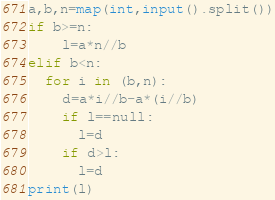<code> <loc_0><loc_0><loc_500><loc_500><_Python_>a,b,n=map(int,input().split())
if b>=n:
	l=a*n//b
elif b<n:
  for i in (b,n):
    d=a*i//b-a*(i//b)
    if l==null:
      l=d
    if d>l:
      l=d
print(l)</code> 